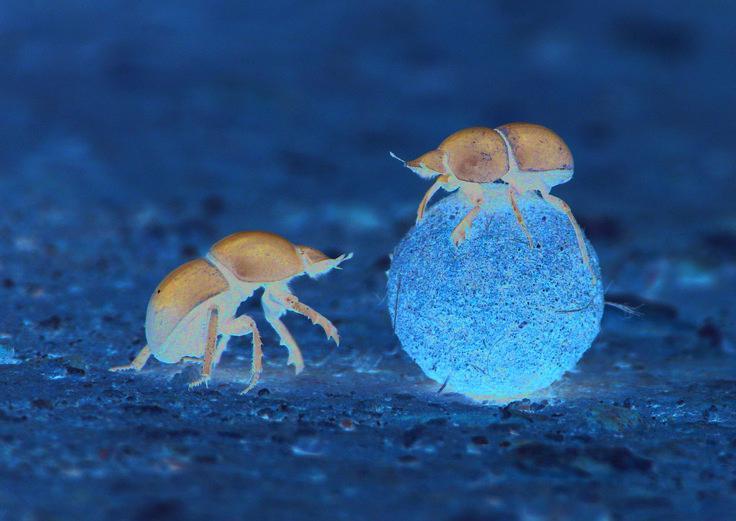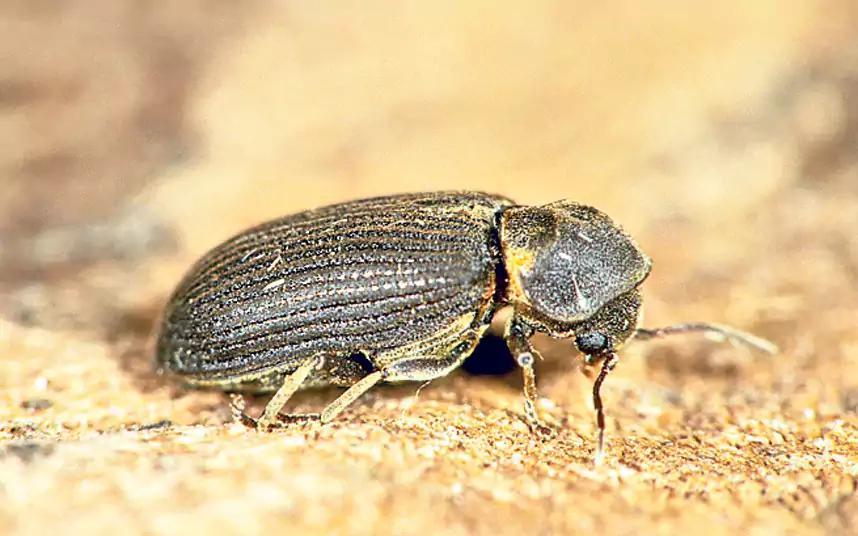The first image is the image on the left, the second image is the image on the right. For the images shown, is this caption "There are two bugs in one of the images." true? Answer yes or no. Yes. 